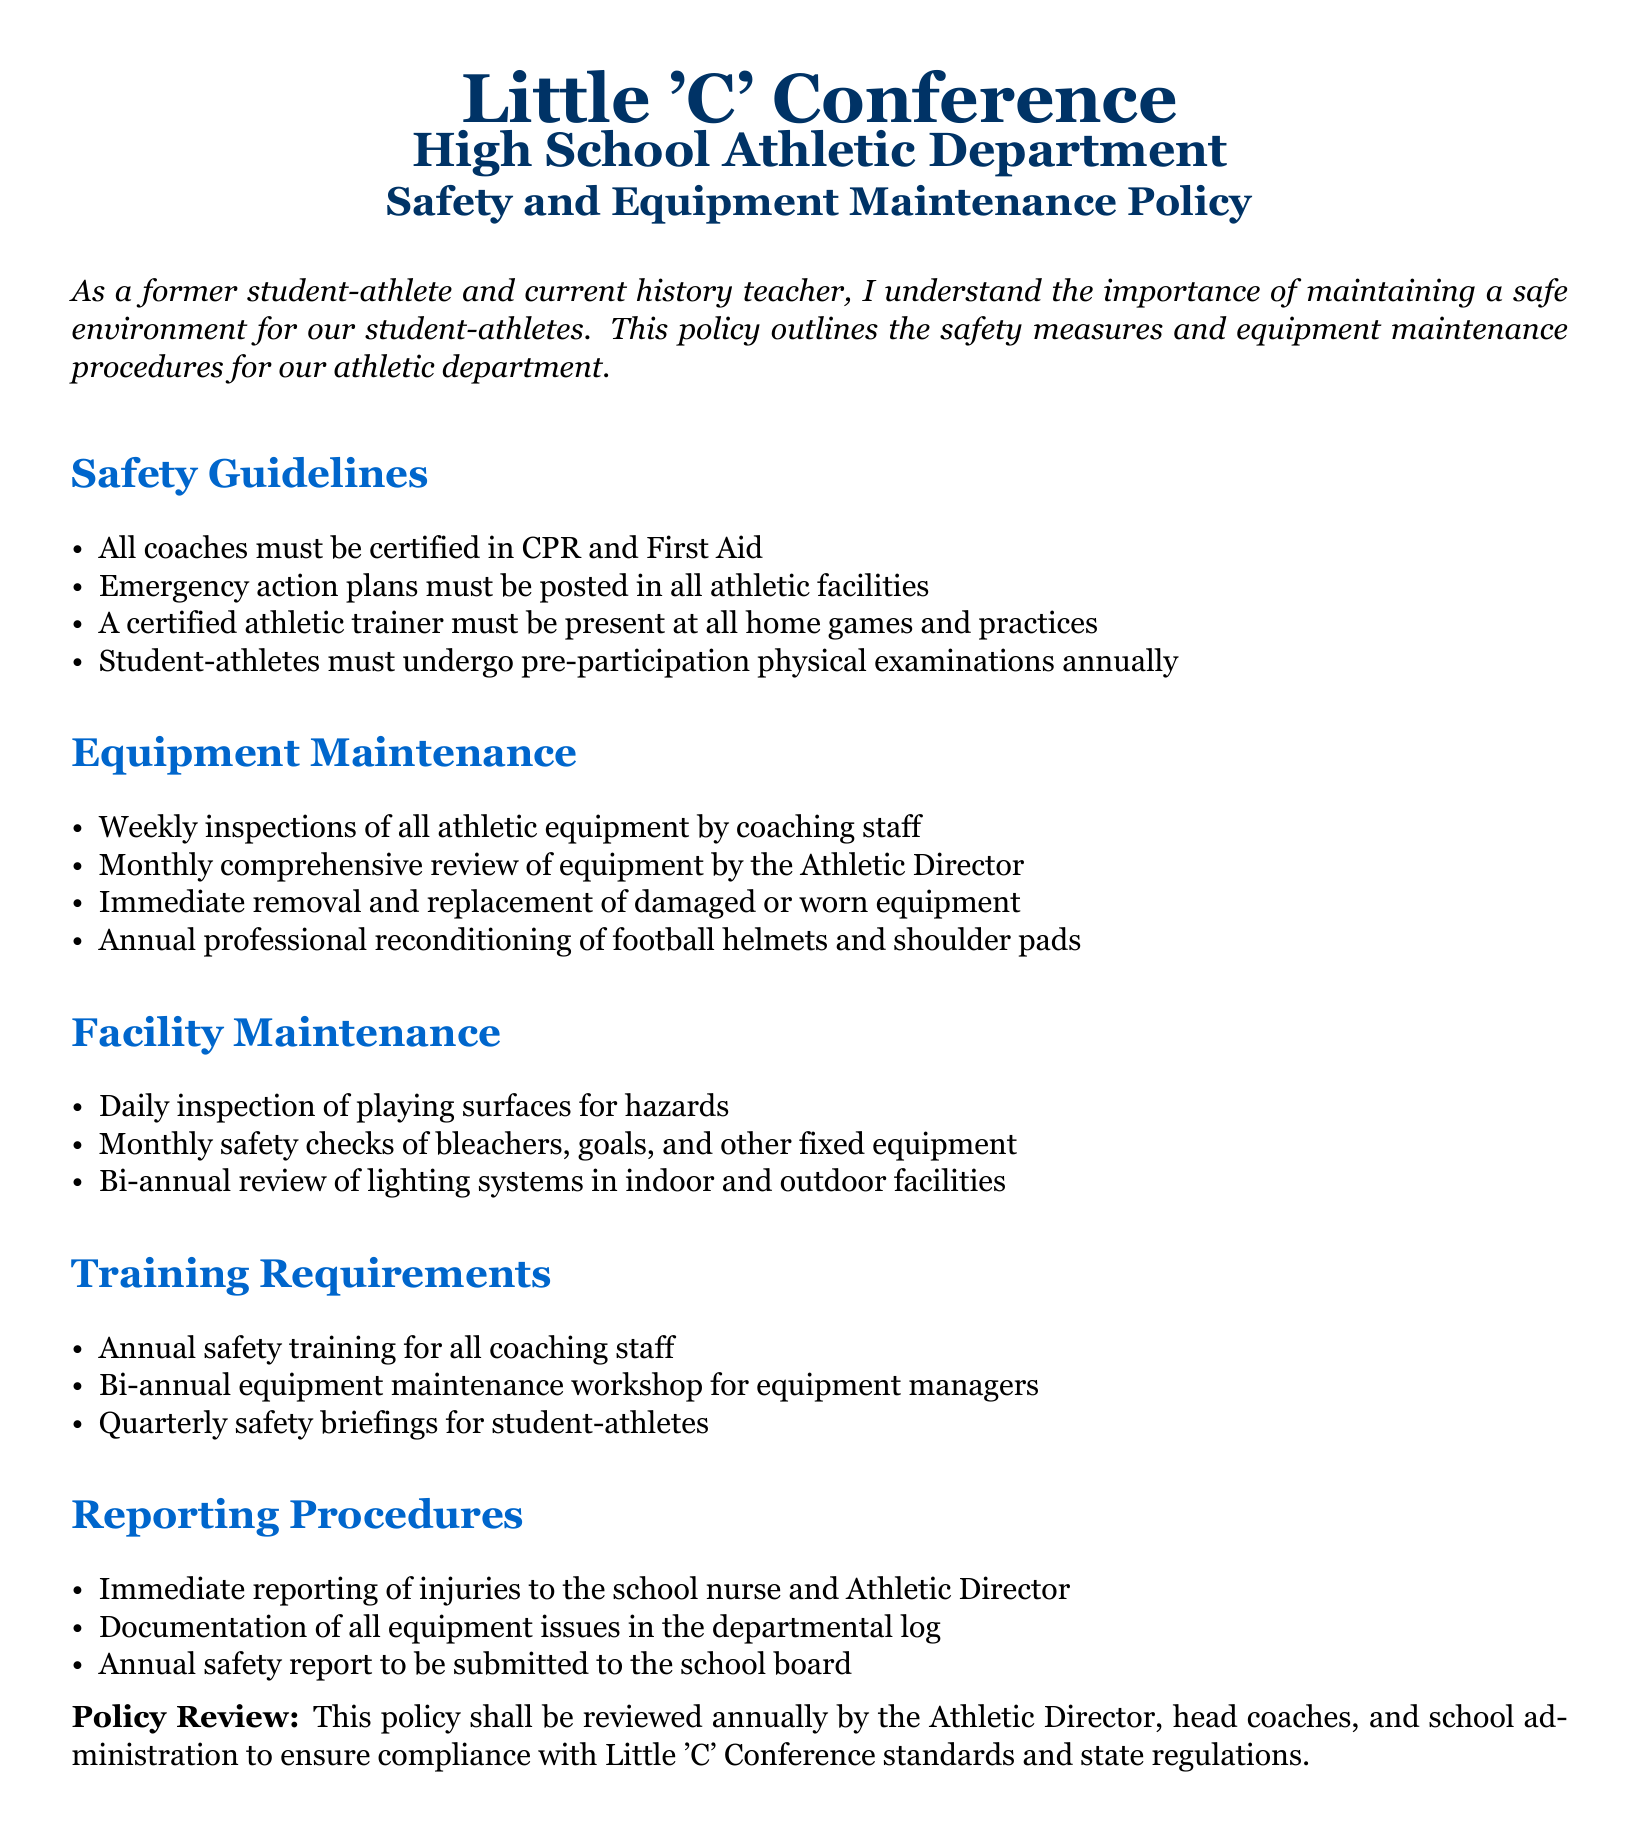What is the frequency of pre-participation physical examinations for student-athletes? The policy states that student-athletes must undergo pre-participation physical examinations annually.
Answer: annually Who must be present at all home games and practices? The document specifies that a certified athletic trainer must be present at all home games and practices.
Answer: certified athletic trainer How often are athletics equipment inspections conducted? According to the document, weekly inspections of all athletic equipment are conducted by coaching staff.
Answer: weekly What is the required training for coaching staff? The document mentions that annual safety training for all coaching staff is required.
Answer: annual safety training Who is responsible for submitting the annual safety report? The policy states that the report must be submitted by the Athletic Director.
Answer: Athletic Director What type of equipment is professionally reconditioned annually? The document notes that football helmets and shoulder pads undergo annual professional reconditioning.
Answer: football helmets and shoulder pads How frequently must the playing surfaces be inspected for hazards? The policy dictates that daily inspections of playing surfaces for hazards must take place.
Answer: daily What is the minimum frequency for safety briefings for student-athletes? The document indicates that safety briefings for student-athletes should occur quarterly.
Answer: quarterly What is the role of the Athletic Director in equipment maintenance? The policy states that the Athletic Director conducts a monthly comprehensive review of equipment.
Answer: monthly comprehensive review of equipment 